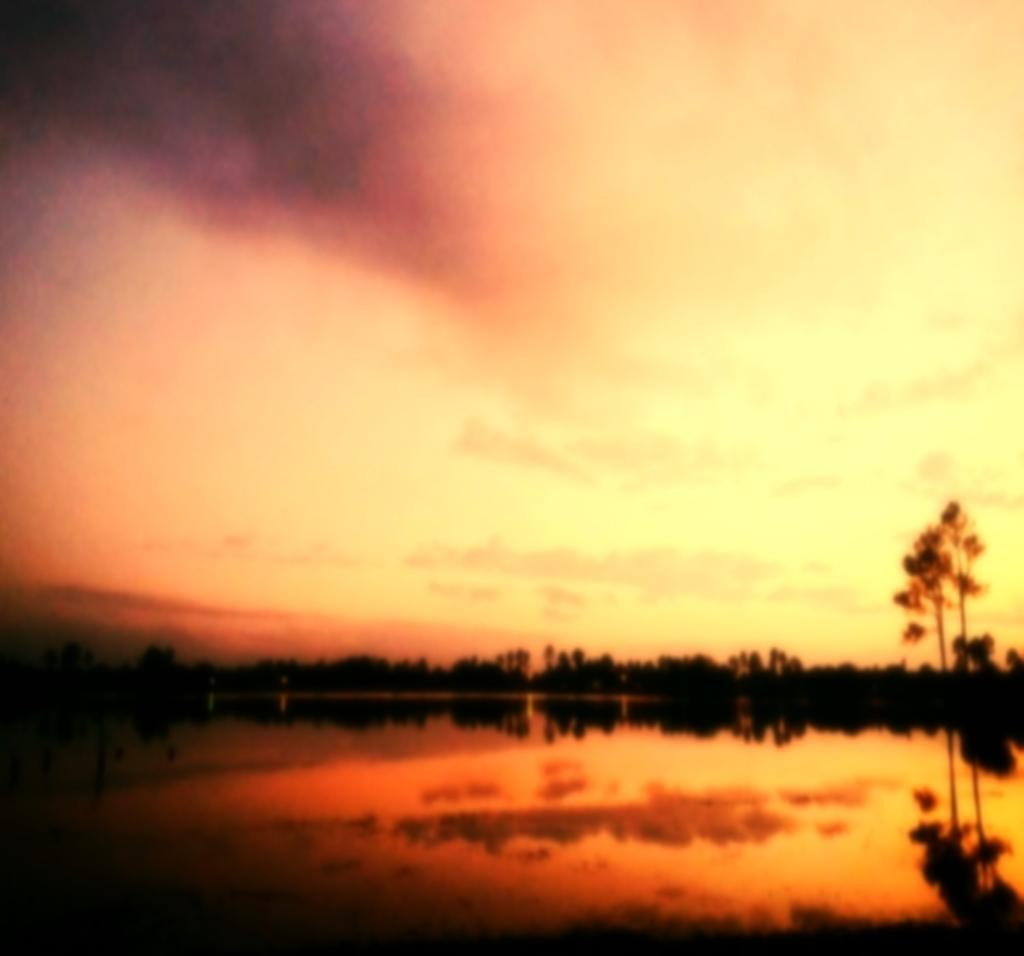What time of day is depicted in the image? The image is taken during sunset. What is located at the bottom of the image? There is a lake at the bottom of the image. What can be seen in the background of the image? There are trees in the background of the image. What type of anger can be seen in the image? There is no anger present in the image; it is a scene of a lake and trees during sunset. Can you tell me how many cherries are floating in the lake in the image? There are no cherries present in the image; it features a lake and trees during sunset. 